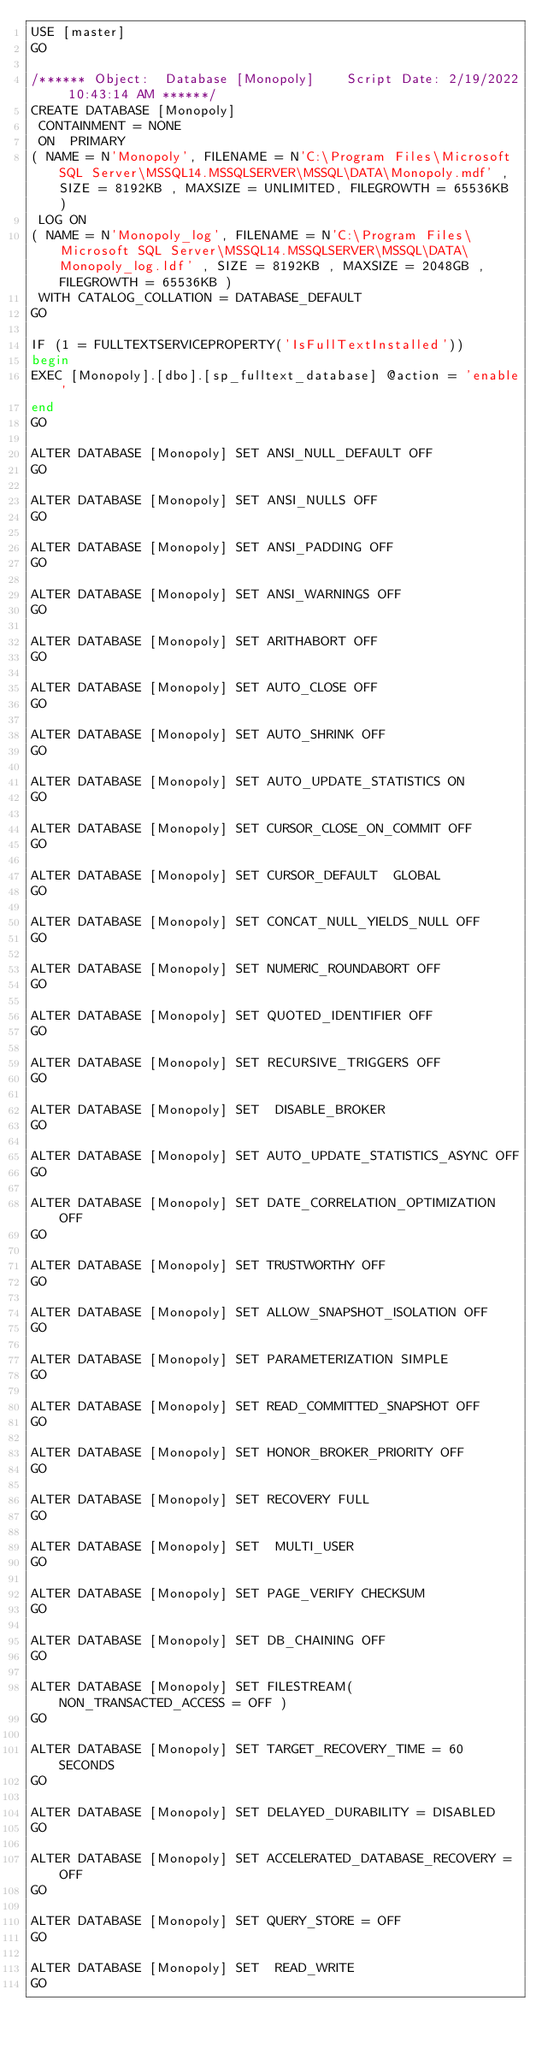Convert code to text. <code><loc_0><loc_0><loc_500><loc_500><_SQL_>USE [master]
GO

/****** Object:  Database [Monopoly]    Script Date: 2/19/2022 10:43:14 AM ******/
CREATE DATABASE [Monopoly]
 CONTAINMENT = NONE
 ON  PRIMARY 
( NAME = N'Monopoly', FILENAME = N'C:\Program Files\Microsoft SQL Server\MSSQL14.MSSQLSERVER\MSSQL\DATA\Monopoly.mdf' , SIZE = 8192KB , MAXSIZE = UNLIMITED, FILEGROWTH = 65536KB )
 LOG ON 
( NAME = N'Monopoly_log', FILENAME = N'C:\Program Files\Microsoft SQL Server\MSSQL14.MSSQLSERVER\MSSQL\DATA\Monopoly_log.ldf' , SIZE = 8192KB , MAXSIZE = 2048GB , FILEGROWTH = 65536KB )
 WITH CATALOG_COLLATION = DATABASE_DEFAULT
GO

IF (1 = FULLTEXTSERVICEPROPERTY('IsFullTextInstalled'))
begin
EXEC [Monopoly].[dbo].[sp_fulltext_database] @action = 'enable'
end
GO

ALTER DATABASE [Monopoly] SET ANSI_NULL_DEFAULT OFF 
GO

ALTER DATABASE [Monopoly] SET ANSI_NULLS OFF 
GO

ALTER DATABASE [Monopoly] SET ANSI_PADDING OFF 
GO

ALTER DATABASE [Monopoly] SET ANSI_WARNINGS OFF 
GO

ALTER DATABASE [Monopoly] SET ARITHABORT OFF 
GO

ALTER DATABASE [Monopoly] SET AUTO_CLOSE OFF 
GO

ALTER DATABASE [Monopoly] SET AUTO_SHRINK OFF 
GO

ALTER DATABASE [Monopoly] SET AUTO_UPDATE_STATISTICS ON 
GO

ALTER DATABASE [Monopoly] SET CURSOR_CLOSE_ON_COMMIT OFF 
GO

ALTER DATABASE [Monopoly] SET CURSOR_DEFAULT  GLOBAL 
GO

ALTER DATABASE [Monopoly] SET CONCAT_NULL_YIELDS_NULL OFF 
GO

ALTER DATABASE [Monopoly] SET NUMERIC_ROUNDABORT OFF 
GO

ALTER DATABASE [Monopoly] SET QUOTED_IDENTIFIER OFF 
GO

ALTER DATABASE [Monopoly] SET RECURSIVE_TRIGGERS OFF 
GO

ALTER DATABASE [Monopoly] SET  DISABLE_BROKER 
GO

ALTER DATABASE [Monopoly] SET AUTO_UPDATE_STATISTICS_ASYNC OFF 
GO

ALTER DATABASE [Monopoly] SET DATE_CORRELATION_OPTIMIZATION OFF 
GO

ALTER DATABASE [Monopoly] SET TRUSTWORTHY OFF 
GO

ALTER DATABASE [Monopoly] SET ALLOW_SNAPSHOT_ISOLATION OFF 
GO

ALTER DATABASE [Monopoly] SET PARAMETERIZATION SIMPLE 
GO

ALTER DATABASE [Monopoly] SET READ_COMMITTED_SNAPSHOT OFF 
GO

ALTER DATABASE [Monopoly] SET HONOR_BROKER_PRIORITY OFF 
GO

ALTER DATABASE [Monopoly] SET RECOVERY FULL 
GO

ALTER DATABASE [Monopoly] SET  MULTI_USER 
GO

ALTER DATABASE [Monopoly] SET PAGE_VERIFY CHECKSUM  
GO

ALTER DATABASE [Monopoly] SET DB_CHAINING OFF 
GO

ALTER DATABASE [Monopoly] SET FILESTREAM( NON_TRANSACTED_ACCESS = OFF ) 
GO

ALTER DATABASE [Monopoly] SET TARGET_RECOVERY_TIME = 60 SECONDS 
GO

ALTER DATABASE [Monopoly] SET DELAYED_DURABILITY = DISABLED 
GO

ALTER DATABASE [Monopoly] SET ACCELERATED_DATABASE_RECOVERY = OFF  
GO

ALTER DATABASE [Monopoly] SET QUERY_STORE = OFF
GO

ALTER DATABASE [Monopoly] SET  READ_WRITE 
GO


</code> 